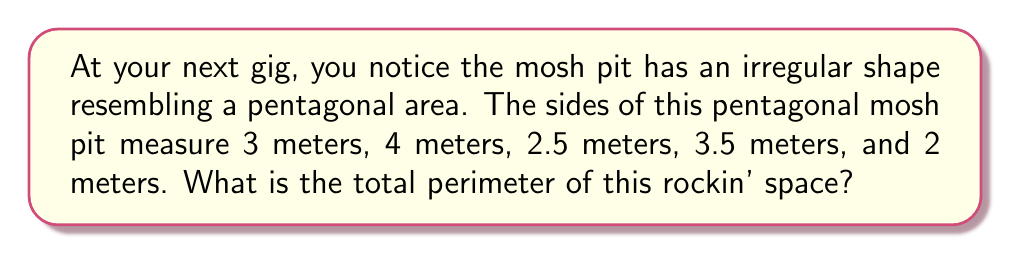Teach me how to tackle this problem. To find the perimeter of the irregularly shaped mosh pit, we need to add up the lengths of all its sides. The pentagonal shape has five sides, and we're given the length of each side.

Let's add them up:

1. First side: 3 meters
2. Second side: 4 meters
3. Third side: 2.5 meters
4. Fourth side: 3.5 meters
5. Fifth side: 2 meters

We can express this mathematically as:

$$\text{Perimeter} = 3 + 4 + 2.5 + 3.5 + 2$$

Now, let's perform the addition:

$$\text{Perimeter} = 15 \text{ meters}$$

This gives us the total distance around the mosh pit, which is its perimeter.

[asy]
unitsize(20);
pair A = (0,0);
pair B = (3,0);
pair C = (5,2);
pair D = (2.5,4);
pair E = (0,2.5);

draw(A--B--C--D--E--A);

label("3m", (A+B)/2, S);
label("4m", (B+C)/2, SE);
label("2.5m", (C+D)/2, NE);
label("3.5m", (D+E)/2, NW);
label("2m", (E+A)/2, W);

dot("A", A, SW);
dot("B", B, SE);
dot("C", C, E);
dot("D", D, N);
dot("E", E, W);
[/asy]
Answer: 15 meters 